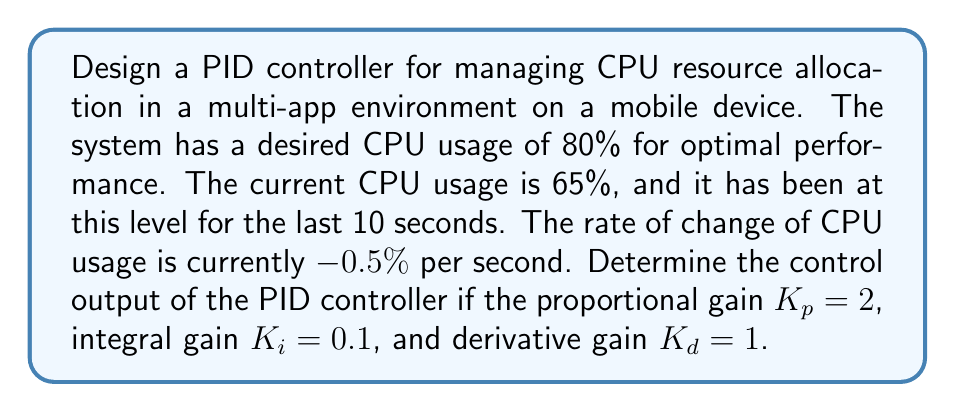Can you solve this math problem? To design a PID controller for this system, we need to calculate the control output based on the given information. The PID controller equation is:

$$u(t) = K_p e(t) + K_i \int_0^t e(\tau) d\tau + K_d \frac{de(t)}{dt}$$

Where:
$u(t)$ is the control output
$e(t)$ is the error (difference between setpoint and measured value)
$K_p$, $K_i$, and $K_d$ are the proportional, integral, and derivative gains, respectively

Step 1: Calculate the error
Error = Setpoint - Measured value
$e(t) = 80\% - 65\% = 15\%$

Step 2: Calculate the integral term
The error has been constant for 10 seconds, so:
$\int_0^t e(\tau) d\tau = 15\% \times 10\text{s} = 150\%\text{s}$

Step 3: Calculate the derivative term
The rate of change of CPU usage is -0.5% per second, so the rate of change of the error is:
$\frac{de(t)}{dt} = -(-0.5\%/\text{s}) = 0.5\%/\text{s}$

Step 4: Apply the PID equation
$$\begin{align*}
u(t) &= K_p e(t) + K_i \int_0^t e(\tau) d\tau + K_d \frac{de(t)}{dt} \\
&= 2 \times 15\% + 0.1 \times 150\%\text{s} + 1 \times 0.5\%/\text{s} \\
&= 30\% + 15\% + 0.5\% \\
&= 45.5\%
\end{align*}$$

Therefore, the control output of the PID controller is 45.5%.
Answer: The control output of the PID controller is 45.5%. 